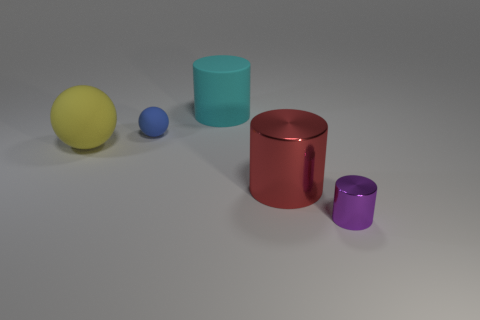Subtract all cyan cylinders. How many cylinders are left? 2 Add 3 purple metal things. How many objects exist? 8 Subtract all cylinders. How many objects are left? 2 Subtract 0 blue cylinders. How many objects are left? 5 Subtract all big gray metallic balls. Subtract all large cyan cylinders. How many objects are left? 4 Add 4 tiny purple things. How many tiny purple things are left? 5 Add 1 large rubber cylinders. How many large rubber cylinders exist? 2 